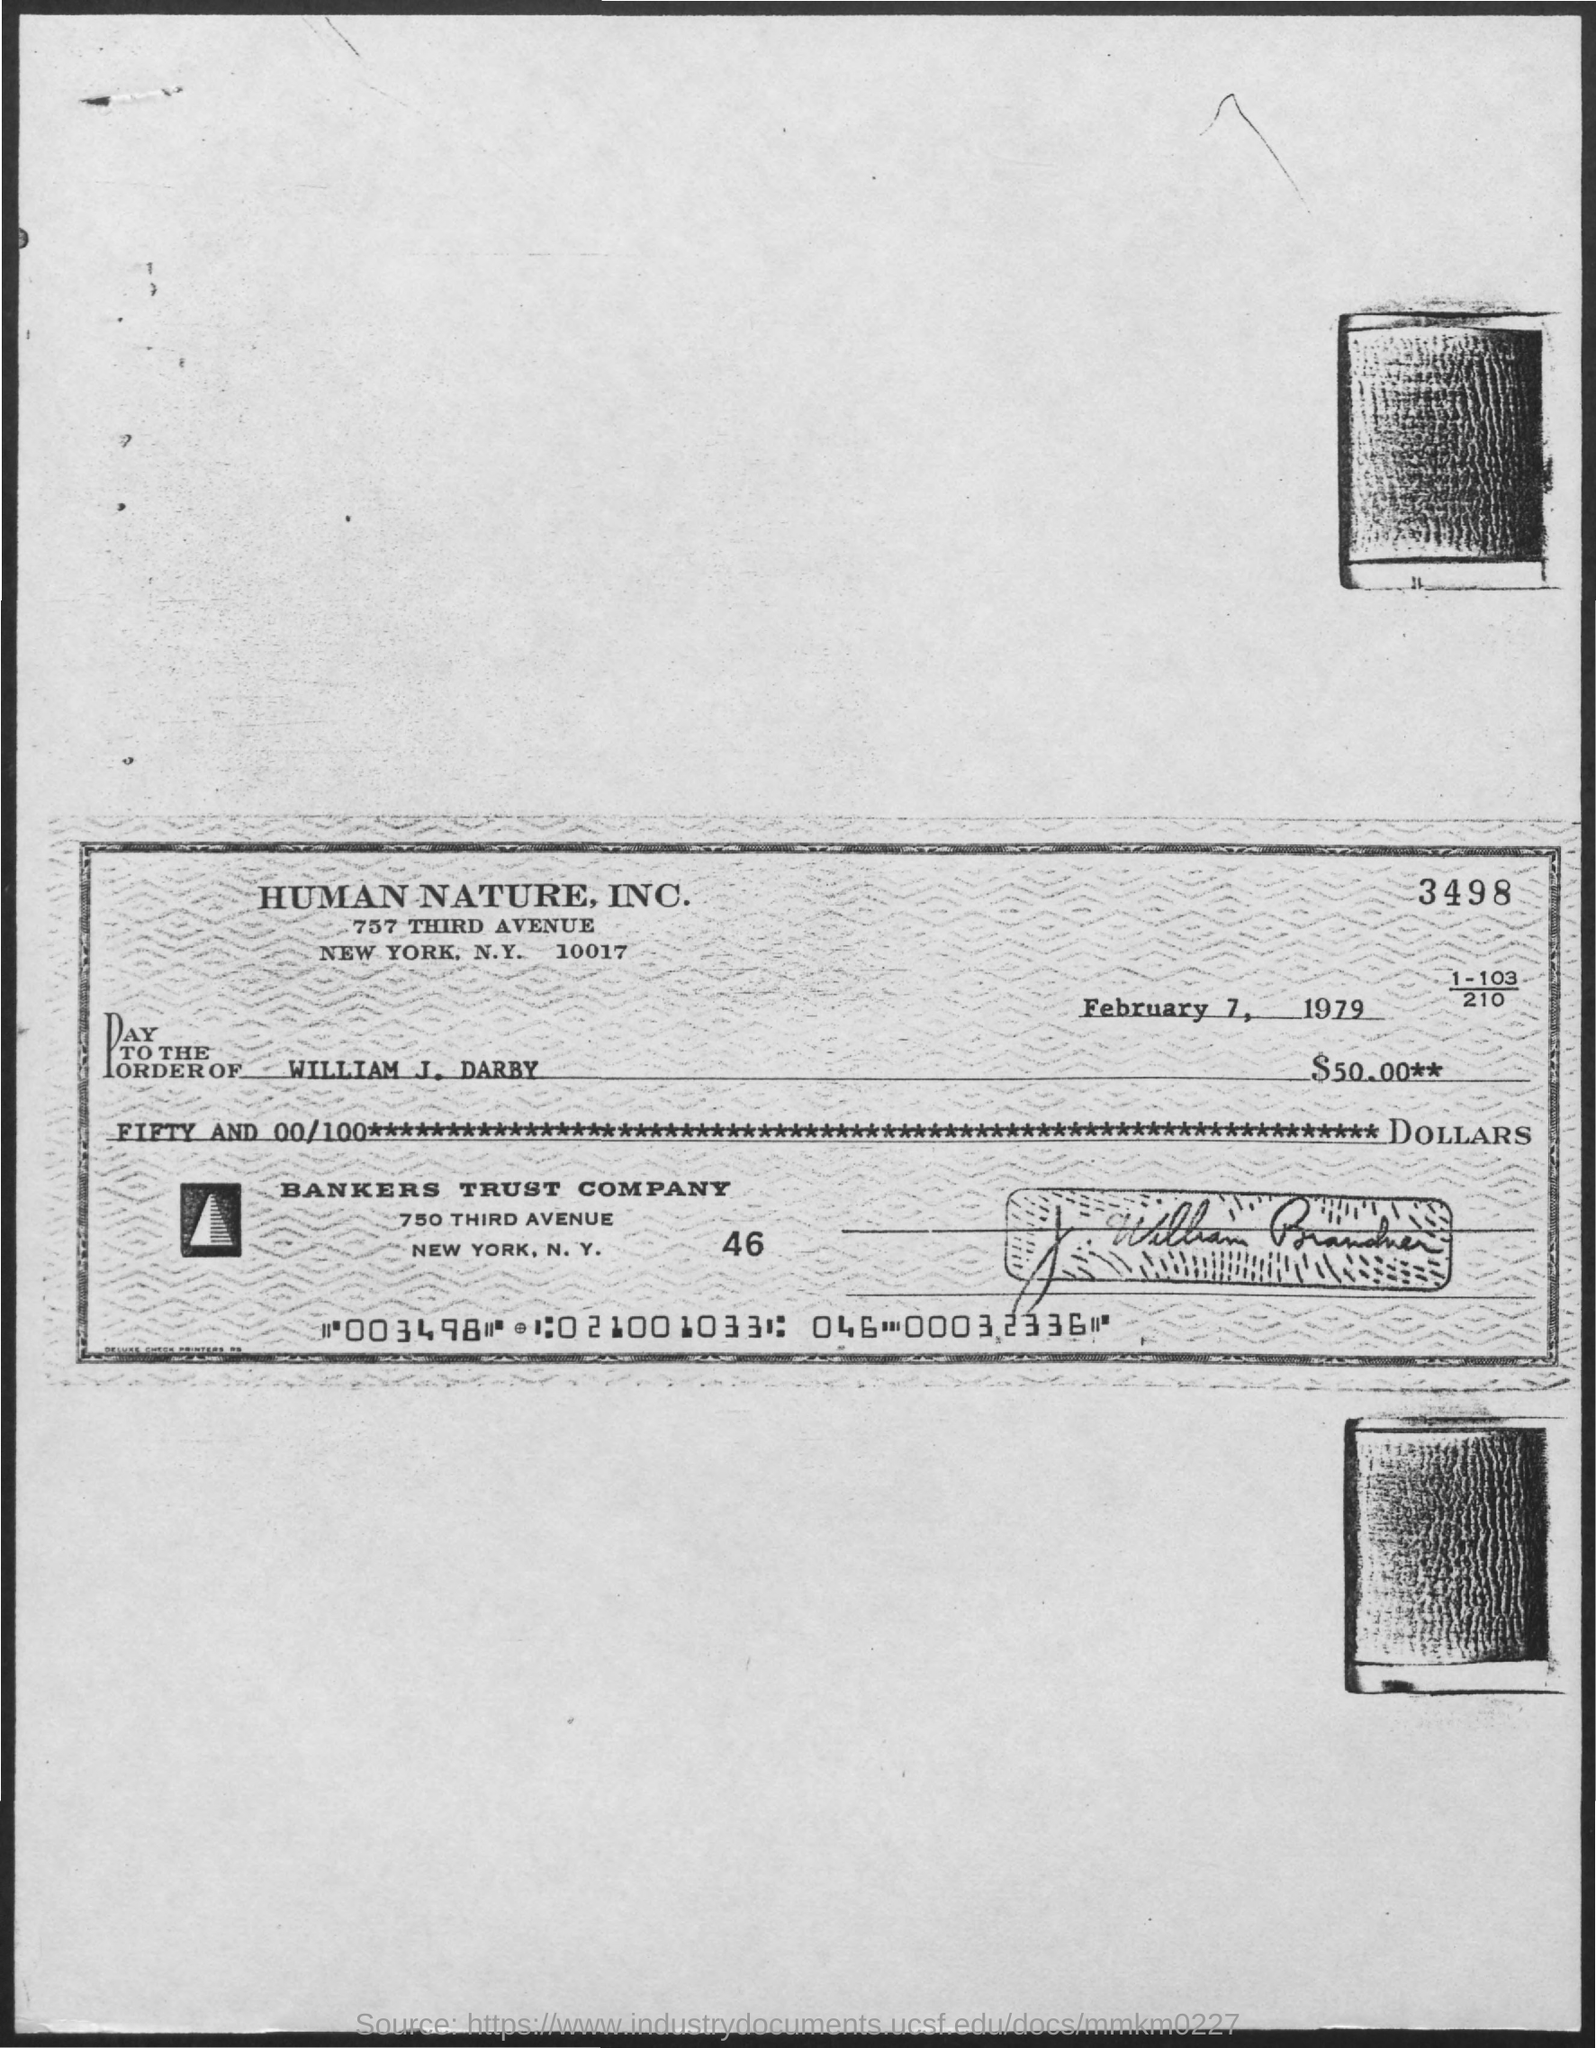Identify some key points in this picture. The amount given on the page is $50. The date mentioned in the given page is February 7, 1979. 